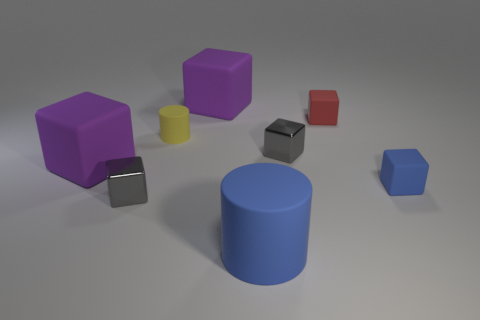The rubber block that is the same color as the large rubber cylinder is what size?
Offer a terse response. Small. How many objects are tiny brown things or rubber objects that are on the right side of the tiny red object?
Offer a terse response. 1. Are there any small gray cubes that have the same material as the red block?
Offer a very short reply. No. What number of objects are in front of the tiny red rubber object and left of the red matte object?
Give a very brief answer. 5. There is a block to the right of the tiny red cube; what is it made of?
Your answer should be compact. Rubber. What size is the red block that is the same material as the blue cylinder?
Your answer should be compact. Small. There is a tiny red cube; are there any small red rubber things behind it?
Keep it short and to the point. No. The blue object that is the same shape as the yellow matte thing is what size?
Give a very brief answer. Large. There is a big cylinder; is its color the same as the small matte object that is behind the yellow matte thing?
Make the answer very short. No. Does the large matte cylinder have the same color as the tiny rubber cylinder?
Your response must be concise. No. 